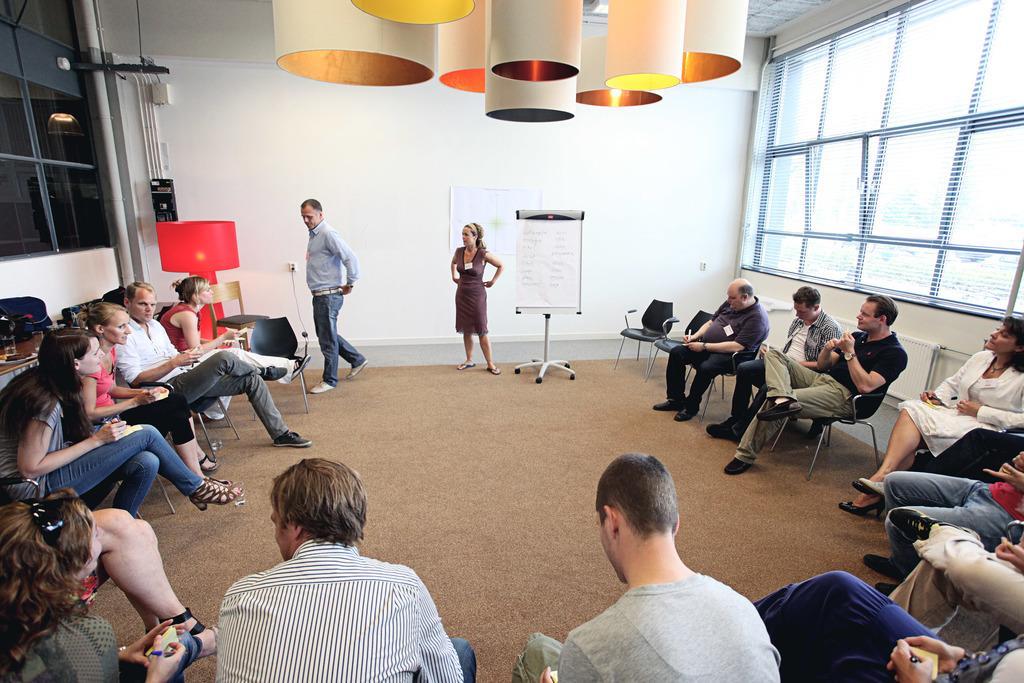How would you summarize this image in a sentence or two? In this image there are group of people sitting on chairs and some of them are writing something, and some of them holding some things. And in the center there is one man and one woman standing, and there is one board. On the board there is text, and in the background there is a wall windows and objects, pipes and some wires. On the right side of the image there are windows, and at the top there are some light and pipes and at the bottom there is floor. 